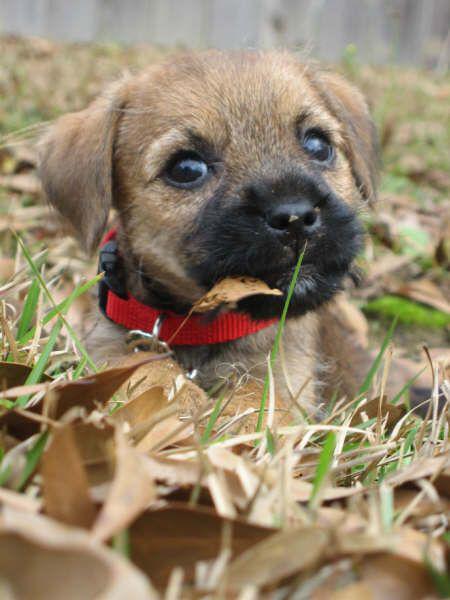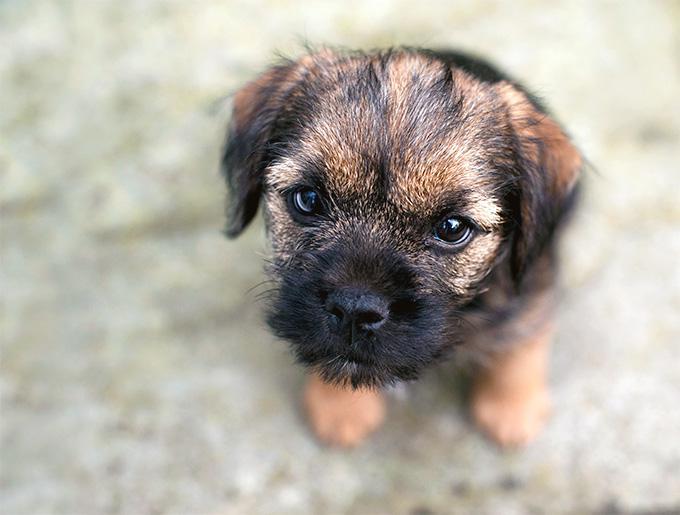The first image is the image on the left, the second image is the image on the right. For the images shown, is this caption "One of the dogs is wearing something colorful around its neck area." true? Answer yes or no. Yes. 